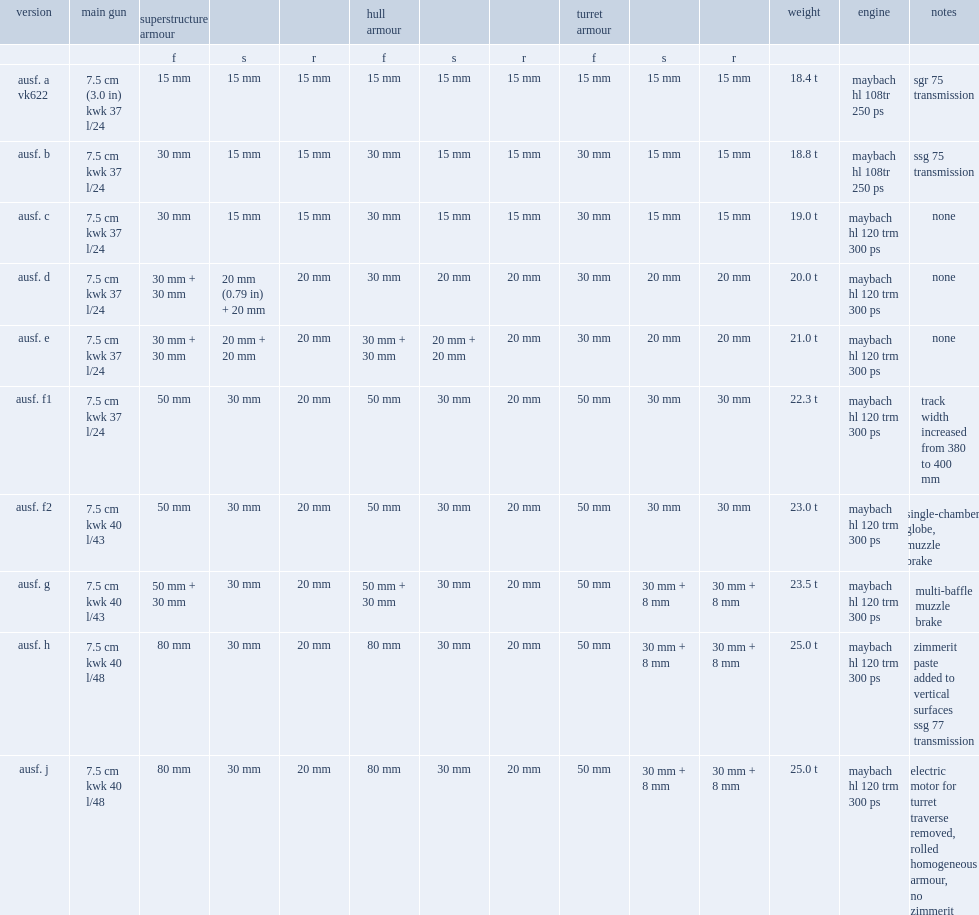What was ausf. f1 vehicle's weight? 22.3 t. 